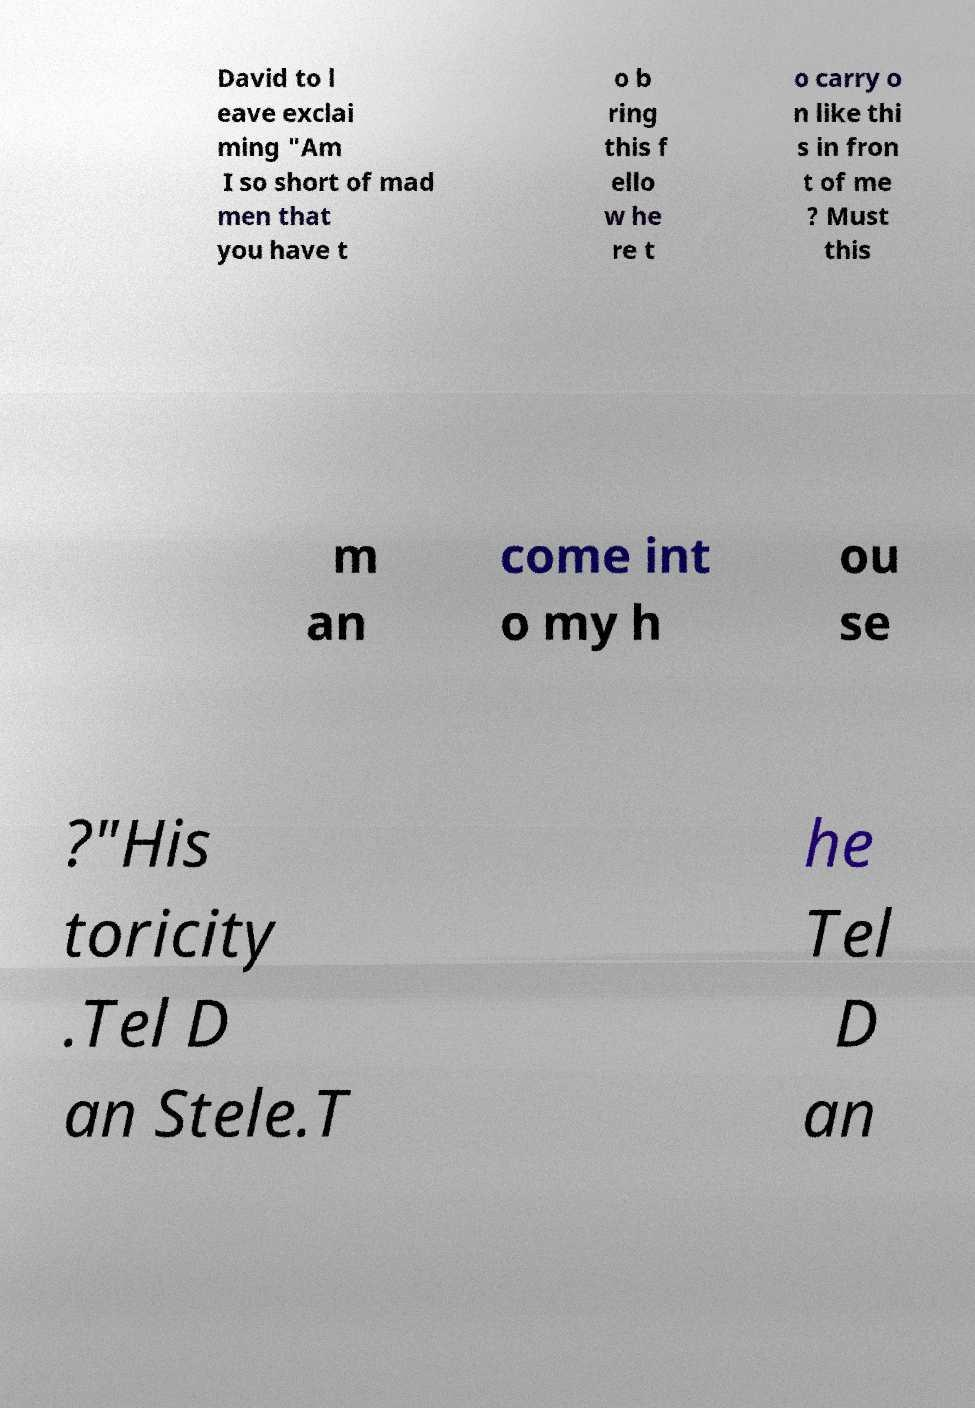Can you accurately transcribe the text from the provided image for me? David to l eave exclai ming "Am I so short of mad men that you have t o b ring this f ello w he re t o carry o n like thi s in fron t of me ? Must this m an come int o my h ou se ?"His toricity .Tel D an Stele.T he Tel D an 